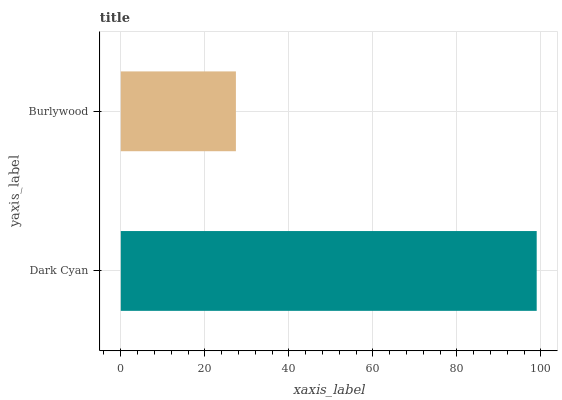Is Burlywood the minimum?
Answer yes or no. Yes. Is Dark Cyan the maximum?
Answer yes or no. Yes. Is Burlywood the maximum?
Answer yes or no. No. Is Dark Cyan greater than Burlywood?
Answer yes or no. Yes. Is Burlywood less than Dark Cyan?
Answer yes or no. Yes. Is Burlywood greater than Dark Cyan?
Answer yes or no. No. Is Dark Cyan less than Burlywood?
Answer yes or no. No. Is Dark Cyan the high median?
Answer yes or no. Yes. Is Burlywood the low median?
Answer yes or no. Yes. Is Burlywood the high median?
Answer yes or no. No. Is Dark Cyan the low median?
Answer yes or no. No. 